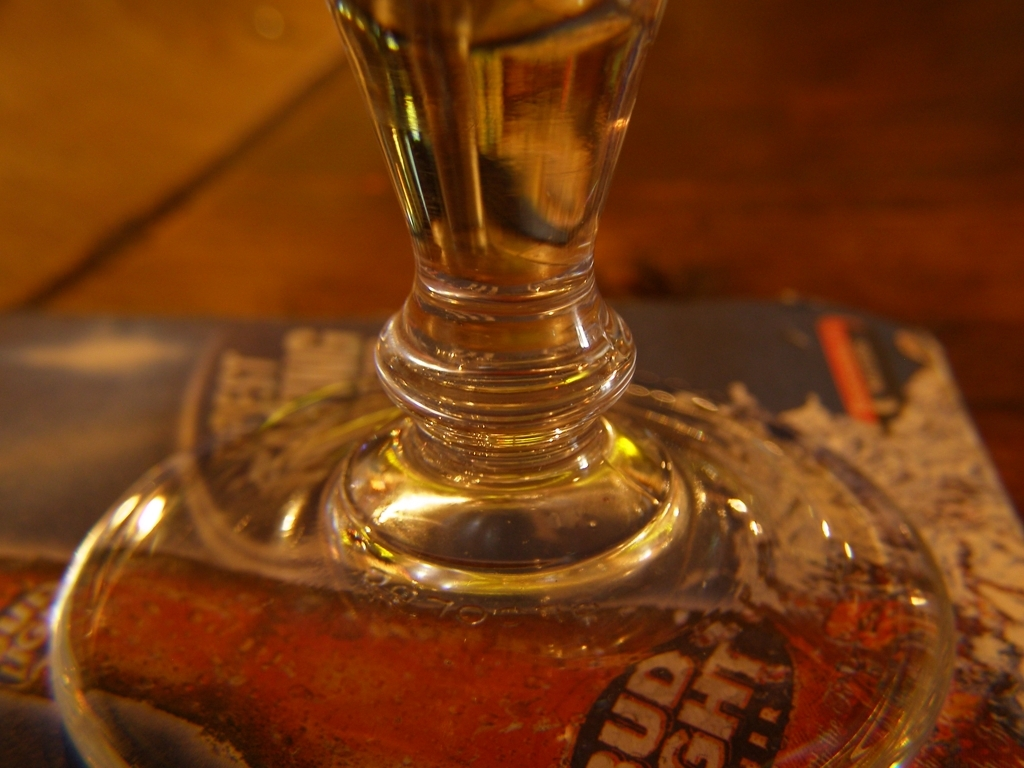What details can you observe on the coaster under the glass? The coaster under the glass has a vintage look, with visible aging and what seems like a weathered logo or text. It adds a nostalgic or rustic charm to the scene. How does the background contribute to the overall mood of the image? The blurred background with earthy tones and subtle patterns complements the foreground, enhancing the warm and inviting ambiance of the setting. 